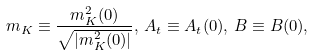<formula> <loc_0><loc_0><loc_500><loc_500>m _ { K } \equiv \frac { m _ { K } ^ { 2 } ( 0 ) } { \sqrt { | m _ { K } ^ { 2 } ( 0 ) | } } , \, A _ { t } \equiv A _ { t } ( 0 ) , \, B \equiv B ( 0 ) ,</formula> 